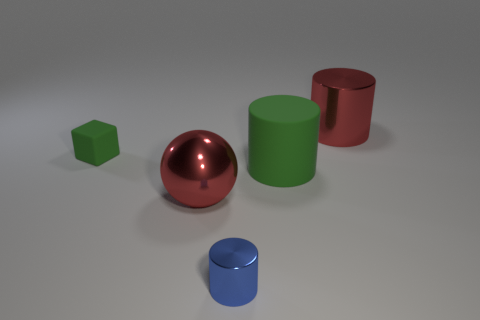Subtract all purple cylinders. Subtract all green cubes. How many cylinders are left? 3 Add 4 big purple metal balls. How many objects exist? 9 Subtract all balls. How many objects are left? 4 Add 1 gray metal spheres. How many gray metal spheres exist? 1 Subtract 0 purple cylinders. How many objects are left? 5 Subtract all large green cylinders. Subtract all tiny things. How many objects are left? 2 Add 3 large red shiny balls. How many large red shiny balls are left? 4 